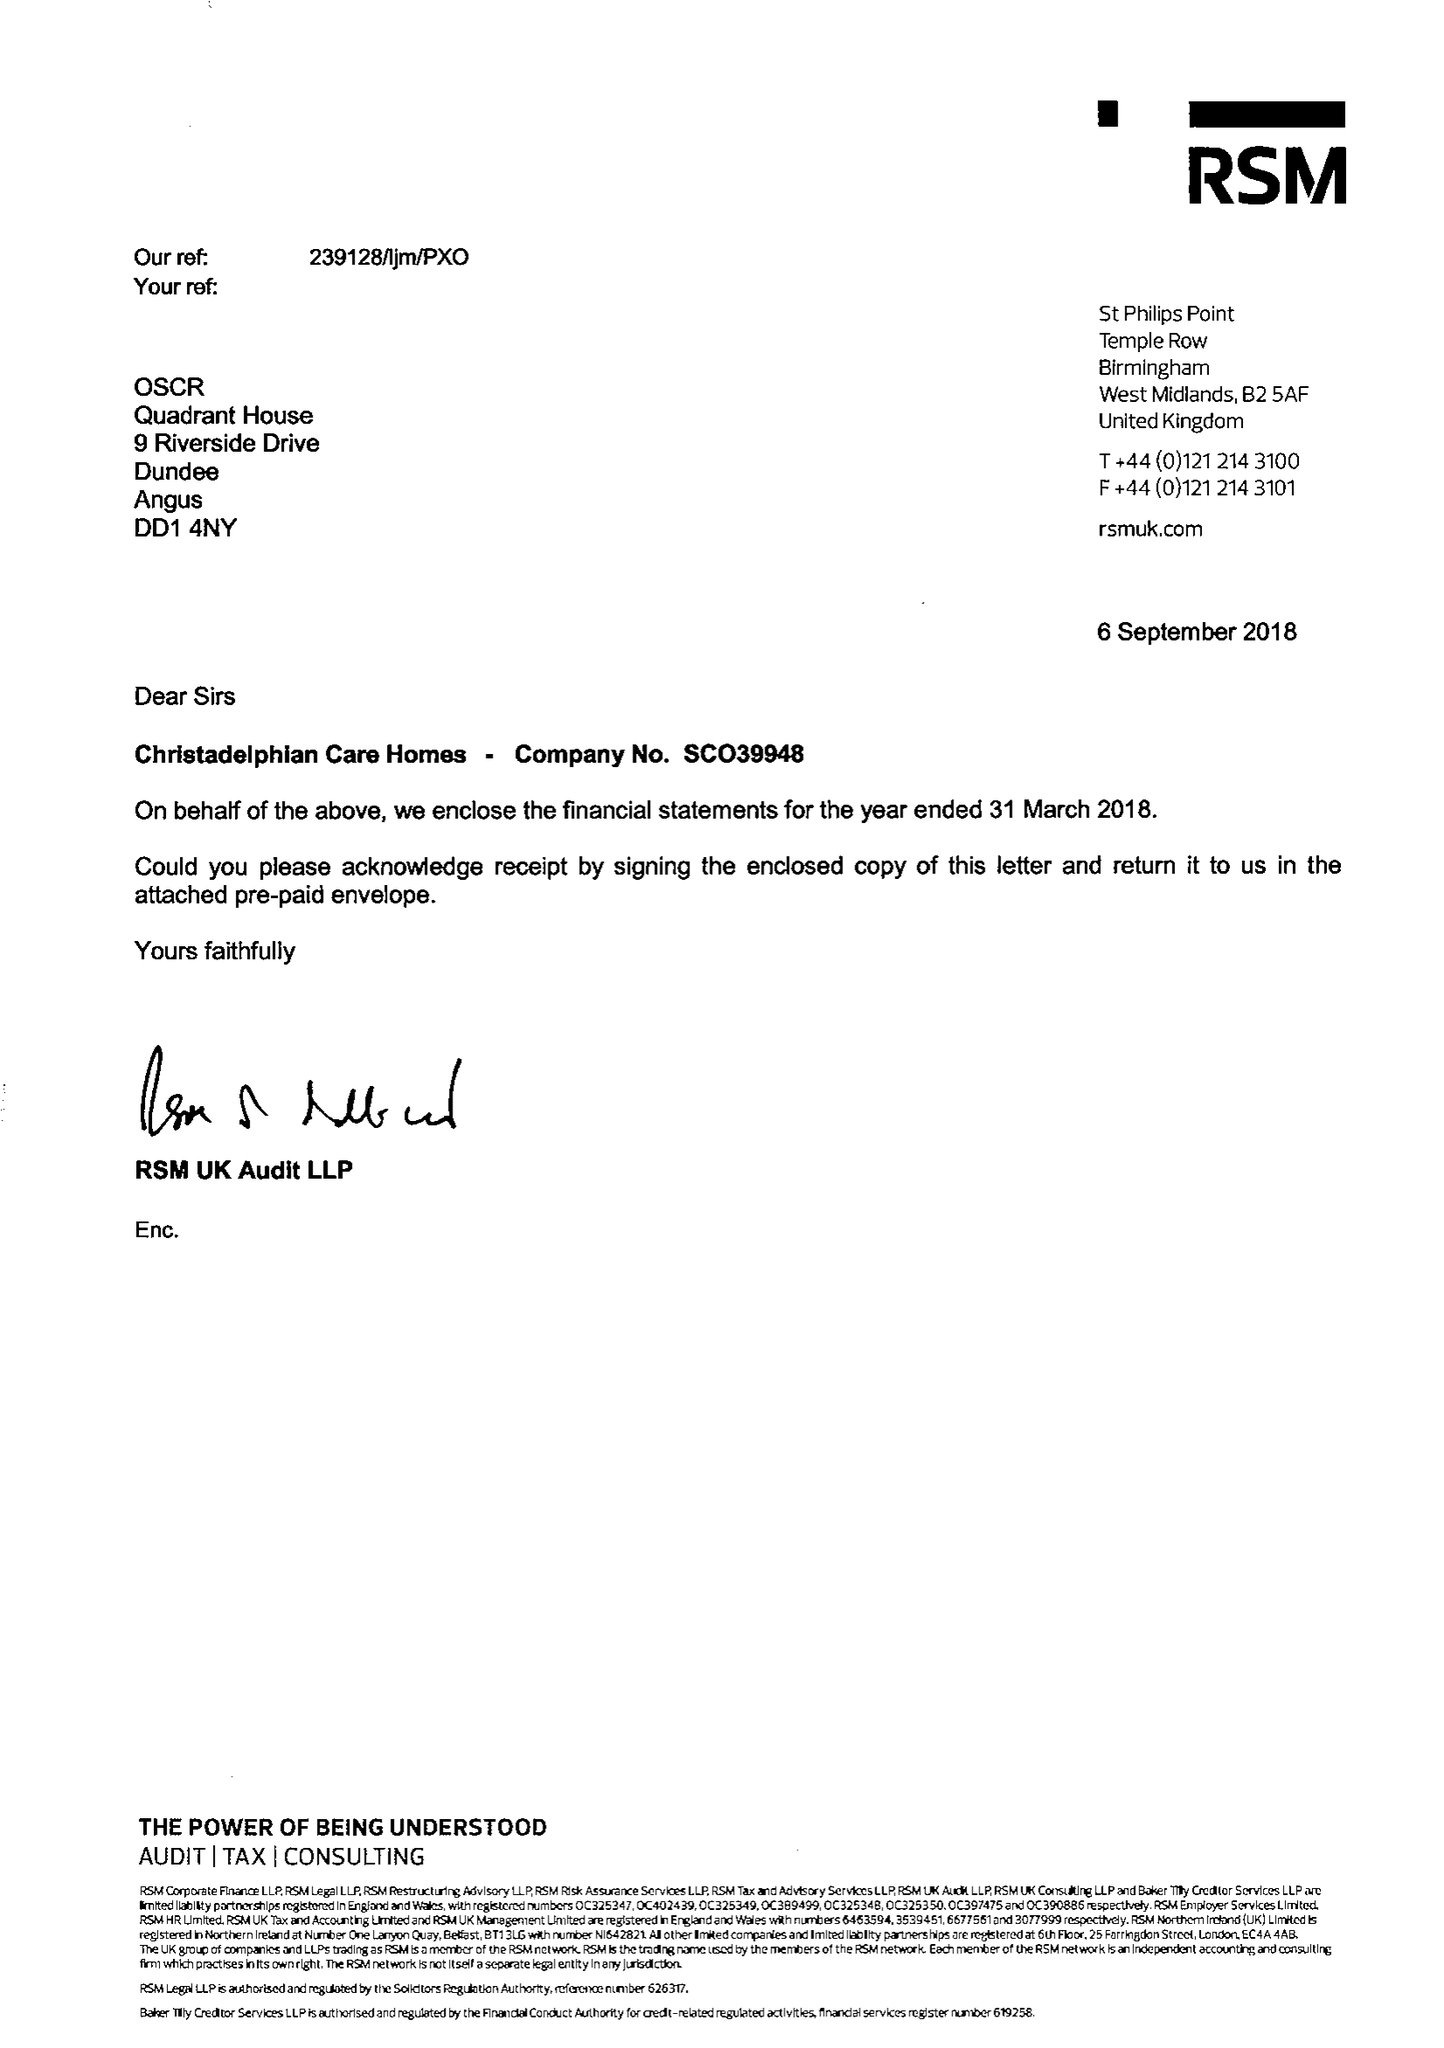What is the value for the income_annually_in_british_pounds?
Answer the question using a single word or phrase. 11160993.00 